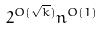Convert formula to latex. <formula><loc_0><loc_0><loc_500><loc_500>2 ^ { O ( \sqrt { k } ) } n ^ { O ( 1 ) }</formula> 